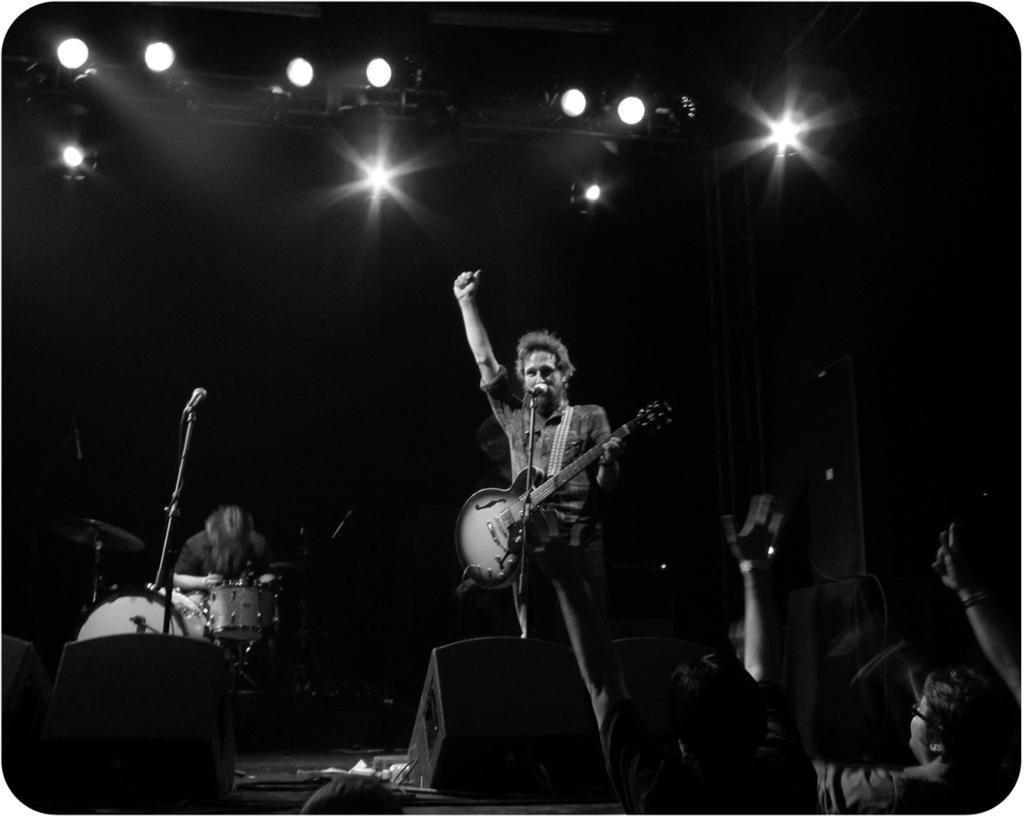Describe this image in one or two sentences. A man is standing and holding a guitar in his hand and there is a mic in front of him and in the background there is another man who is playing drums. And in the top we can see lights and in the bottom we can see the crowd and to the left side we can see the musical instruments and the man standing with a guitar in his hand is singing 